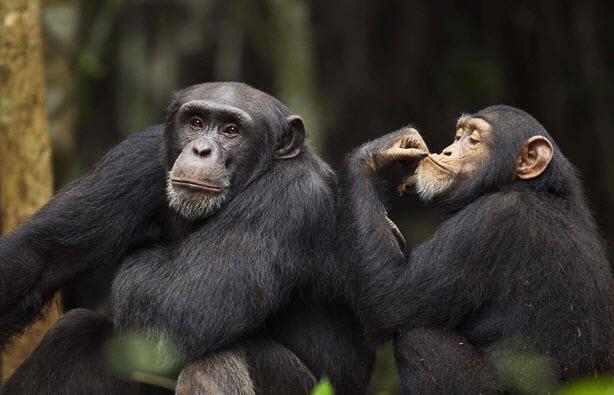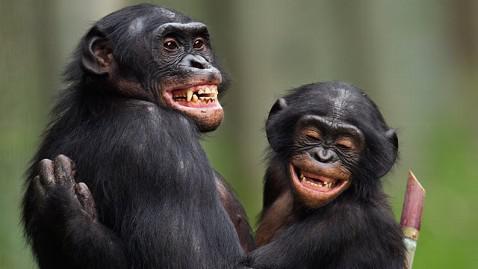The first image is the image on the left, the second image is the image on the right. Given the left and right images, does the statement "An image shows an adult and a younger chimp chest to chest in a hugging pose." hold true? Answer yes or no. Yes. The first image is the image on the left, the second image is the image on the right. Considering the images on both sides, is "In one image, two chimpanzees are hugging, while one chimpanzee in a second image has its left arm raised to head level." valid? Answer yes or no. Yes. 